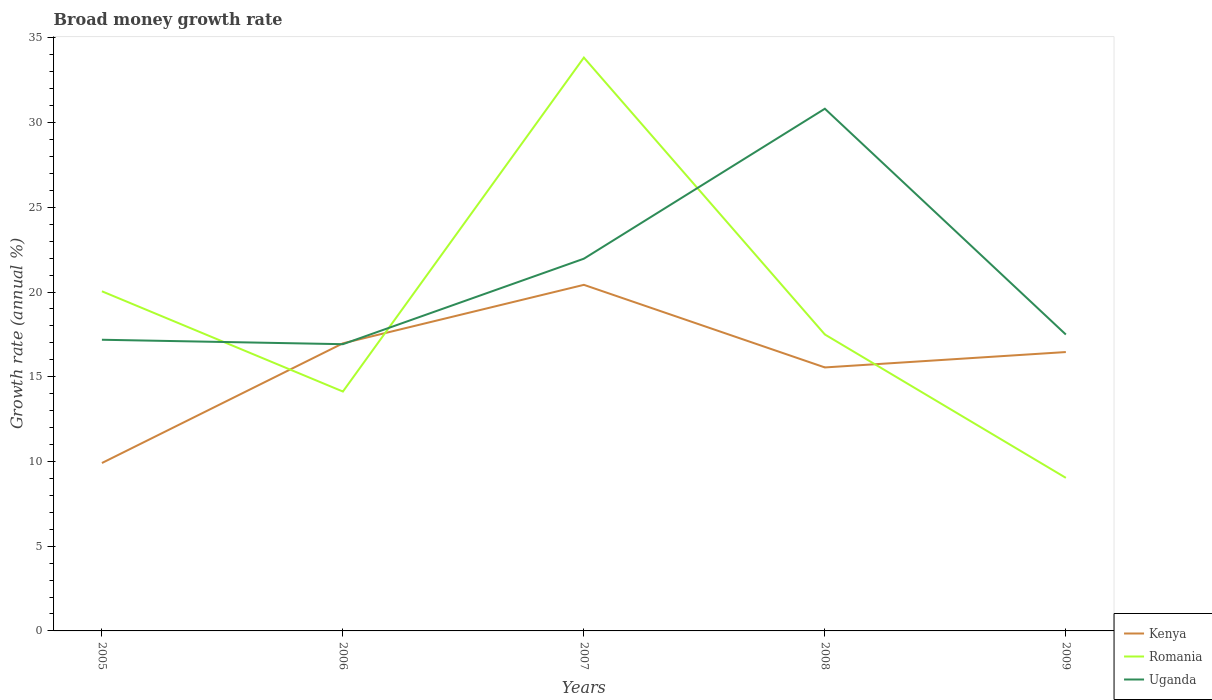Across all years, what is the maximum growth rate in Uganda?
Keep it short and to the point. 16.92. In which year was the growth rate in Kenya maximum?
Your answer should be compact. 2005. What is the total growth rate in Romania in the graph?
Offer a terse response. -3.37. What is the difference between the highest and the second highest growth rate in Kenya?
Make the answer very short. 10.51. What is the difference between the highest and the lowest growth rate in Uganda?
Your answer should be compact. 2. Is the growth rate in Uganda strictly greater than the growth rate in Romania over the years?
Your answer should be very brief. No. How many lines are there?
Your answer should be very brief. 3. How many years are there in the graph?
Make the answer very short. 5. What is the difference between two consecutive major ticks on the Y-axis?
Ensure brevity in your answer.  5. Does the graph contain any zero values?
Give a very brief answer. No. Does the graph contain grids?
Keep it short and to the point. No. How many legend labels are there?
Your answer should be compact. 3. What is the title of the graph?
Offer a very short reply. Broad money growth rate. What is the label or title of the X-axis?
Ensure brevity in your answer.  Years. What is the label or title of the Y-axis?
Offer a very short reply. Growth rate (annual %). What is the Growth rate (annual %) in Kenya in 2005?
Your response must be concise. 9.91. What is the Growth rate (annual %) of Romania in 2005?
Your answer should be compact. 20.04. What is the Growth rate (annual %) in Uganda in 2005?
Offer a terse response. 17.18. What is the Growth rate (annual %) in Kenya in 2006?
Make the answer very short. 16.97. What is the Growth rate (annual %) of Romania in 2006?
Make the answer very short. 14.13. What is the Growth rate (annual %) of Uganda in 2006?
Provide a succinct answer. 16.92. What is the Growth rate (annual %) of Kenya in 2007?
Your answer should be very brief. 20.42. What is the Growth rate (annual %) in Romania in 2007?
Your answer should be very brief. 33.83. What is the Growth rate (annual %) of Uganda in 2007?
Provide a short and direct response. 21.97. What is the Growth rate (annual %) of Kenya in 2008?
Your response must be concise. 15.55. What is the Growth rate (annual %) of Romania in 2008?
Your response must be concise. 17.49. What is the Growth rate (annual %) in Uganda in 2008?
Offer a very short reply. 30.82. What is the Growth rate (annual %) in Kenya in 2009?
Your answer should be compact. 16.46. What is the Growth rate (annual %) in Romania in 2009?
Offer a terse response. 9.03. What is the Growth rate (annual %) in Uganda in 2009?
Provide a succinct answer. 17.49. Across all years, what is the maximum Growth rate (annual %) of Kenya?
Your response must be concise. 20.42. Across all years, what is the maximum Growth rate (annual %) of Romania?
Ensure brevity in your answer.  33.83. Across all years, what is the maximum Growth rate (annual %) of Uganda?
Offer a very short reply. 30.82. Across all years, what is the minimum Growth rate (annual %) in Kenya?
Ensure brevity in your answer.  9.91. Across all years, what is the minimum Growth rate (annual %) of Romania?
Keep it short and to the point. 9.03. Across all years, what is the minimum Growth rate (annual %) in Uganda?
Your answer should be compact. 16.92. What is the total Growth rate (annual %) in Kenya in the graph?
Your answer should be compact. 79.31. What is the total Growth rate (annual %) in Romania in the graph?
Ensure brevity in your answer.  94.53. What is the total Growth rate (annual %) of Uganda in the graph?
Offer a very short reply. 104.38. What is the difference between the Growth rate (annual %) of Kenya in 2005 and that in 2006?
Your response must be concise. -7.06. What is the difference between the Growth rate (annual %) of Romania in 2005 and that in 2006?
Your answer should be very brief. 5.92. What is the difference between the Growth rate (annual %) of Uganda in 2005 and that in 2006?
Ensure brevity in your answer.  0.26. What is the difference between the Growth rate (annual %) of Kenya in 2005 and that in 2007?
Keep it short and to the point. -10.51. What is the difference between the Growth rate (annual %) of Romania in 2005 and that in 2007?
Your answer should be compact. -13.79. What is the difference between the Growth rate (annual %) in Uganda in 2005 and that in 2007?
Give a very brief answer. -4.78. What is the difference between the Growth rate (annual %) in Kenya in 2005 and that in 2008?
Offer a very short reply. -5.64. What is the difference between the Growth rate (annual %) in Romania in 2005 and that in 2008?
Give a very brief answer. 2.55. What is the difference between the Growth rate (annual %) of Uganda in 2005 and that in 2008?
Keep it short and to the point. -13.63. What is the difference between the Growth rate (annual %) in Kenya in 2005 and that in 2009?
Provide a succinct answer. -6.55. What is the difference between the Growth rate (annual %) of Romania in 2005 and that in 2009?
Your response must be concise. 11.01. What is the difference between the Growth rate (annual %) of Uganda in 2005 and that in 2009?
Keep it short and to the point. -0.31. What is the difference between the Growth rate (annual %) of Kenya in 2006 and that in 2007?
Make the answer very short. -3.45. What is the difference between the Growth rate (annual %) in Romania in 2006 and that in 2007?
Keep it short and to the point. -19.71. What is the difference between the Growth rate (annual %) in Uganda in 2006 and that in 2007?
Your answer should be compact. -5.05. What is the difference between the Growth rate (annual %) of Kenya in 2006 and that in 2008?
Ensure brevity in your answer.  1.42. What is the difference between the Growth rate (annual %) of Romania in 2006 and that in 2008?
Make the answer very short. -3.37. What is the difference between the Growth rate (annual %) of Uganda in 2006 and that in 2008?
Provide a short and direct response. -13.9. What is the difference between the Growth rate (annual %) of Kenya in 2006 and that in 2009?
Offer a very short reply. 0.51. What is the difference between the Growth rate (annual %) of Romania in 2006 and that in 2009?
Give a very brief answer. 5.09. What is the difference between the Growth rate (annual %) in Uganda in 2006 and that in 2009?
Your response must be concise. -0.57. What is the difference between the Growth rate (annual %) of Kenya in 2007 and that in 2008?
Your answer should be compact. 4.87. What is the difference between the Growth rate (annual %) in Romania in 2007 and that in 2008?
Give a very brief answer. 16.34. What is the difference between the Growth rate (annual %) of Uganda in 2007 and that in 2008?
Your answer should be very brief. -8.85. What is the difference between the Growth rate (annual %) in Kenya in 2007 and that in 2009?
Give a very brief answer. 3.97. What is the difference between the Growth rate (annual %) of Romania in 2007 and that in 2009?
Keep it short and to the point. 24.8. What is the difference between the Growth rate (annual %) of Uganda in 2007 and that in 2009?
Give a very brief answer. 4.48. What is the difference between the Growth rate (annual %) in Kenya in 2008 and that in 2009?
Ensure brevity in your answer.  -0.91. What is the difference between the Growth rate (annual %) of Romania in 2008 and that in 2009?
Your response must be concise. 8.46. What is the difference between the Growth rate (annual %) in Uganda in 2008 and that in 2009?
Provide a short and direct response. 13.33. What is the difference between the Growth rate (annual %) in Kenya in 2005 and the Growth rate (annual %) in Romania in 2006?
Ensure brevity in your answer.  -4.22. What is the difference between the Growth rate (annual %) in Kenya in 2005 and the Growth rate (annual %) in Uganda in 2006?
Your answer should be compact. -7.01. What is the difference between the Growth rate (annual %) in Romania in 2005 and the Growth rate (annual %) in Uganda in 2006?
Provide a succinct answer. 3.12. What is the difference between the Growth rate (annual %) of Kenya in 2005 and the Growth rate (annual %) of Romania in 2007?
Offer a very short reply. -23.93. What is the difference between the Growth rate (annual %) of Kenya in 2005 and the Growth rate (annual %) of Uganda in 2007?
Your response must be concise. -12.06. What is the difference between the Growth rate (annual %) of Romania in 2005 and the Growth rate (annual %) of Uganda in 2007?
Your answer should be very brief. -1.92. What is the difference between the Growth rate (annual %) of Kenya in 2005 and the Growth rate (annual %) of Romania in 2008?
Ensure brevity in your answer.  -7.59. What is the difference between the Growth rate (annual %) of Kenya in 2005 and the Growth rate (annual %) of Uganda in 2008?
Your answer should be very brief. -20.91. What is the difference between the Growth rate (annual %) in Romania in 2005 and the Growth rate (annual %) in Uganda in 2008?
Your response must be concise. -10.77. What is the difference between the Growth rate (annual %) of Kenya in 2005 and the Growth rate (annual %) of Uganda in 2009?
Make the answer very short. -7.58. What is the difference between the Growth rate (annual %) in Romania in 2005 and the Growth rate (annual %) in Uganda in 2009?
Offer a very short reply. 2.55. What is the difference between the Growth rate (annual %) of Kenya in 2006 and the Growth rate (annual %) of Romania in 2007?
Keep it short and to the point. -16.86. What is the difference between the Growth rate (annual %) in Kenya in 2006 and the Growth rate (annual %) in Uganda in 2007?
Your response must be concise. -4.99. What is the difference between the Growth rate (annual %) of Romania in 2006 and the Growth rate (annual %) of Uganda in 2007?
Your response must be concise. -7.84. What is the difference between the Growth rate (annual %) of Kenya in 2006 and the Growth rate (annual %) of Romania in 2008?
Provide a succinct answer. -0.52. What is the difference between the Growth rate (annual %) in Kenya in 2006 and the Growth rate (annual %) in Uganda in 2008?
Give a very brief answer. -13.84. What is the difference between the Growth rate (annual %) in Romania in 2006 and the Growth rate (annual %) in Uganda in 2008?
Offer a very short reply. -16.69. What is the difference between the Growth rate (annual %) of Kenya in 2006 and the Growth rate (annual %) of Romania in 2009?
Offer a very short reply. 7.94. What is the difference between the Growth rate (annual %) of Kenya in 2006 and the Growth rate (annual %) of Uganda in 2009?
Your answer should be compact. -0.52. What is the difference between the Growth rate (annual %) in Romania in 2006 and the Growth rate (annual %) in Uganda in 2009?
Your response must be concise. -3.36. What is the difference between the Growth rate (annual %) in Kenya in 2007 and the Growth rate (annual %) in Romania in 2008?
Make the answer very short. 2.93. What is the difference between the Growth rate (annual %) of Kenya in 2007 and the Growth rate (annual %) of Uganda in 2008?
Your answer should be compact. -10.39. What is the difference between the Growth rate (annual %) of Romania in 2007 and the Growth rate (annual %) of Uganda in 2008?
Keep it short and to the point. 3.02. What is the difference between the Growth rate (annual %) in Kenya in 2007 and the Growth rate (annual %) in Romania in 2009?
Provide a short and direct response. 11.39. What is the difference between the Growth rate (annual %) of Kenya in 2007 and the Growth rate (annual %) of Uganda in 2009?
Make the answer very short. 2.93. What is the difference between the Growth rate (annual %) in Romania in 2007 and the Growth rate (annual %) in Uganda in 2009?
Your answer should be very brief. 16.34. What is the difference between the Growth rate (annual %) in Kenya in 2008 and the Growth rate (annual %) in Romania in 2009?
Offer a very short reply. 6.52. What is the difference between the Growth rate (annual %) in Kenya in 2008 and the Growth rate (annual %) in Uganda in 2009?
Your response must be concise. -1.94. What is the difference between the Growth rate (annual %) in Romania in 2008 and the Growth rate (annual %) in Uganda in 2009?
Your response must be concise. 0. What is the average Growth rate (annual %) of Kenya per year?
Your answer should be compact. 15.86. What is the average Growth rate (annual %) of Romania per year?
Give a very brief answer. 18.91. What is the average Growth rate (annual %) of Uganda per year?
Provide a succinct answer. 20.88. In the year 2005, what is the difference between the Growth rate (annual %) in Kenya and Growth rate (annual %) in Romania?
Offer a very short reply. -10.13. In the year 2005, what is the difference between the Growth rate (annual %) of Kenya and Growth rate (annual %) of Uganda?
Your response must be concise. -7.27. In the year 2005, what is the difference between the Growth rate (annual %) in Romania and Growth rate (annual %) in Uganda?
Ensure brevity in your answer.  2.86. In the year 2006, what is the difference between the Growth rate (annual %) in Kenya and Growth rate (annual %) in Romania?
Your answer should be very brief. 2.85. In the year 2006, what is the difference between the Growth rate (annual %) in Kenya and Growth rate (annual %) in Uganda?
Offer a terse response. 0.05. In the year 2006, what is the difference between the Growth rate (annual %) of Romania and Growth rate (annual %) of Uganda?
Provide a short and direct response. -2.79. In the year 2007, what is the difference between the Growth rate (annual %) in Kenya and Growth rate (annual %) in Romania?
Your answer should be compact. -13.41. In the year 2007, what is the difference between the Growth rate (annual %) in Kenya and Growth rate (annual %) in Uganda?
Offer a terse response. -1.54. In the year 2007, what is the difference between the Growth rate (annual %) of Romania and Growth rate (annual %) of Uganda?
Provide a succinct answer. 11.87. In the year 2008, what is the difference between the Growth rate (annual %) in Kenya and Growth rate (annual %) in Romania?
Your answer should be very brief. -1.94. In the year 2008, what is the difference between the Growth rate (annual %) of Kenya and Growth rate (annual %) of Uganda?
Provide a succinct answer. -15.27. In the year 2008, what is the difference between the Growth rate (annual %) of Romania and Growth rate (annual %) of Uganda?
Ensure brevity in your answer.  -13.32. In the year 2009, what is the difference between the Growth rate (annual %) of Kenya and Growth rate (annual %) of Romania?
Your answer should be compact. 7.42. In the year 2009, what is the difference between the Growth rate (annual %) in Kenya and Growth rate (annual %) in Uganda?
Your answer should be very brief. -1.03. In the year 2009, what is the difference between the Growth rate (annual %) in Romania and Growth rate (annual %) in Uganda?
Ensure brevity in your answer.  -8.46. What is the ratio of the Growth rate (annual %) in Kenya in 2005 to that in 2006?
Make the answer very short. 0.58. What is the ratio of the Growth rate (annual %) of Romania in 2005 to that in 2006?
Make the answer very short. 1.42. What is the ratio of the Growth rate (annual %) of Uganda in 2005 to that in 2006?
Provide a short and direct response. 1.02. What is the ratio of the Growth rate (annual %) of Kenya in 2005 to that in 2007?
Your answer should be very brief. 0.49. What is the ratio of the Growth rate (annual %) in Romania in 2005 to that in 2007?
Your answer should be compact. 0.59. What is the ratio of the Growth rate (annual %) of Uganda in 2005 to that in 2007?
Offer a very short reply. 0.78. What is the ratio of the Growth rate (annual %) of Kenya in 2005 to that in 2008?
Your response must be concise. 0.64. What is the ratio of the Growth rate (annual %) in Romania in 2005 to that in 2008?
Your response must be concise. 1.15. What is the ratio of the Growth rate (annual %) in Uganda in 2005 to that in 2008?
Offer a very short reply. 0.56. What is the ratio of the Growth rate (annual %) in Kenya in 2005 to that in 2009?
Offer a terse response. 0.6. What is the ratio of the Growth rate (annual %) of Romania in 2005 to that in 2009?
Your response must be concise. 2.22. What is the ratio of the Growth rate (annual %) of Uganda in 2005 to that in 2009?
Provide a succinct answer. 0.98. What is the ratio of the Growth rate (annual %) of Kenya in 2006 to that in 2007?
Ensure brevity in your answer.  0.83. What is the ratio of the Growth rate (annual %) in Romania in 2006 to that in 2007?
Ensure brevity in your answer.  0.42. What is the ratio of the Growth rate (annual %) of Uganda in 2006 to that in 2007?
Provide a short and direct response. 0.77. What is the ratio of the Growth rate (annual %) in Kenya in 2006 to that in 2008?
Offer a terse response. 1.09. What is the ratio of the Growth rate (annual %) in Romania in 2006 to that in 2008?
Your response must be concise. 0.81. What is the ratio of the Growth rate (annual %) of Uganda in 2006 to that in 2008?
Offer a very short reply. 0.55. What is the ratio of the Growth rate (annual %) in Kenya in 2006 to that in 2009?
Provide a short and direct response. 1.03. What is the ratio of the Growth rate (annual %) in Romania in 2006 to that in 2009?
Offer a very short reply. 1.56. What is the ratio of the Growth rate (annual %) of Uganda in 2006 to that in 2009?
Offer a terse response. 0.97. What is the ratio of the Growth rate (annual %) in Kenya in 2007 to that in 2008?
Ensure brevity in your answer.  1.31. What is the ratio of the Growth rate (annual %) of Romania in 2007 to that in 2008?
Provide a short and direct response. 1.93. What is the ratio of the Growth rate (annual %) in Uganda in 2007 to that in 2008?
Provide a succinct answer. 0.71. What is the ratio of the Growth rate (annual %) of Kenya in 2007 to that in 2009?
Your answer should be compact. 1.24. What is the ratio of the Growth rate (annual %) of Romania in 2007 to that in 2009?
Offer a terse response. 3.75. What is the ratio of the Growth rate (annual %) in Uganda in 2007 to that in 2009?
Offer a very short reply. 1.26. What is the ratio of the Growth rate (annual %) of Kenya in 2008 to that in 2009?
Provide a short and direct response. 0.94. What is the ratio of the Growth rate (annual %) of Romania in 2008 to that in 2009?
Provide a short and direct response. 1.94. What is the ratio of the Growth rate (annual %) in Uganda in 2008 to that in 2009?
Your answer should be compact. 1.76. What is the difference between the highest and the second highest Growth rate (annual %) in Kenya?
Provide a short and direct response. 3.45. What is the difference between the highest and the second highest Growth rate (annual %) in Romania?
Ensure brevity in your answer.  13.79. What is the difference between the highest and the second highest Growth rate (annual %) in Uganda?
Provide a succinct answer. 8.85. What is the difference between the highest and the lowest Growth rate (annual %) of Kenya?
Keep it short and to the point. 10.51. What is the difference between the highest and the lowest Growth rate (annual %) in Romania?
Provide a succinct answer. 24.8. What is the difference between the highest and the lowest Growth rate (annual %) in Uganda?
Keep it short and to the point. 13.9. 